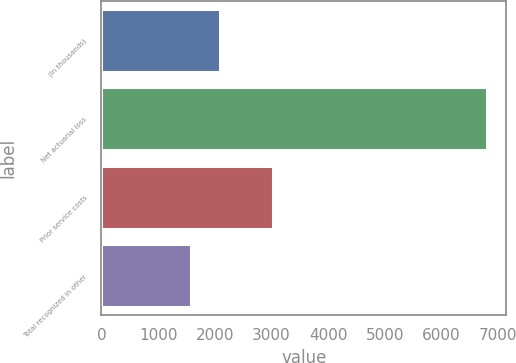<chart> <loc_0><loc_0><loc_500><loc_500><bar_chart><fcel>(In thousands)<fcel>Net actuarial loss<fcel>Prior service costs<fcel>Total recognized in other<nl><fcel>2097<fcel>6795<fcel>3023<fcel>1575<nl></chart> 